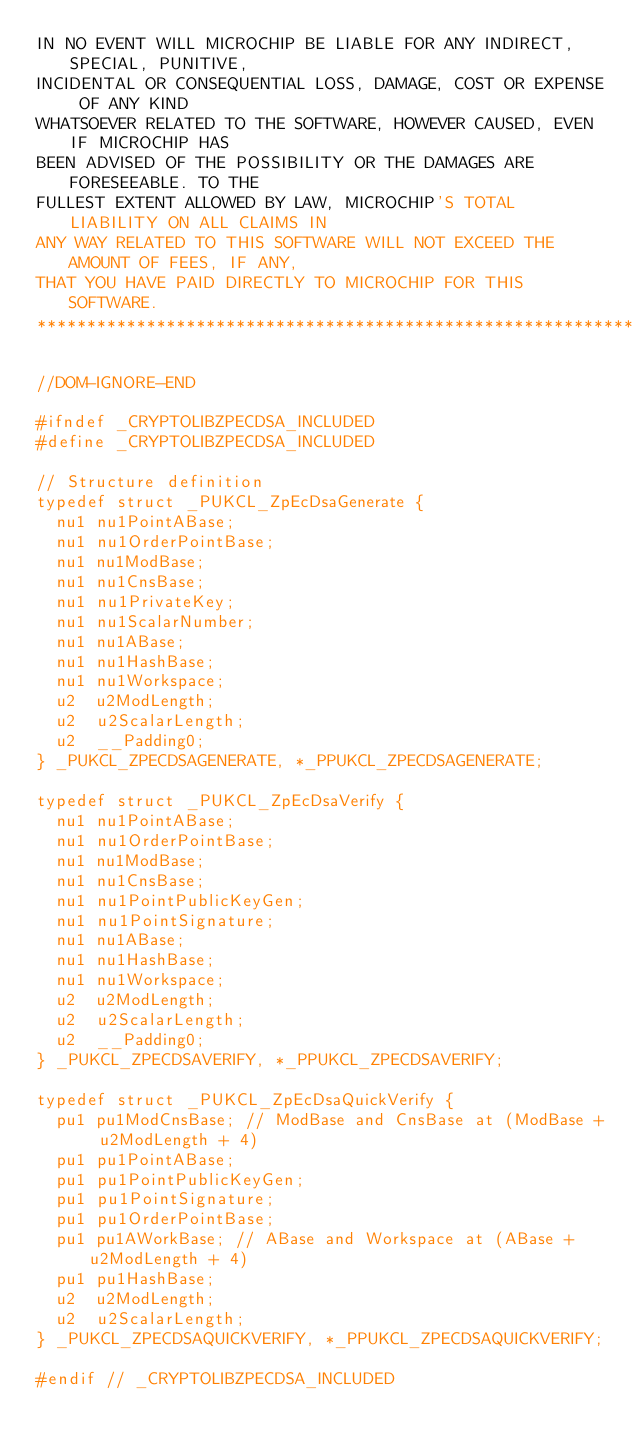Convert code to text. <code><loc_0><loc_0><loc_500><loc_500><_C_>IN NO EVENT WILL MICROCHIP BE LIABLE FOR ANY INDIRECT, SPECIAL, PUNITIVE, 
INCIDENTAL OR CONSEQUENTIAL LOSS, DAMAGE, COST OR EXPENSE OF ANY KIND 
WHATSOEVER RELATED TO THE SOFTWARE, HOWEVER CAUSED, EVEN IF MICROCHIP HAS 
BEEN ADVISED OF THE POSSIBILITY OR THE DAMAGES ARE FORESEEABLE. TO THE 
FULLEST EXTENT ALLOWED BY LAW, MICROCHIP'S TOTAL LIABILITY ON ALL CLAIMS IN 
ANY WAY RELATED TO THIS SOFTWARE WILL NOT EXCEED THE AMOUNT OF FEES, IF ANY, 
THAT YOU HAVE PAID DIRECTLY TO MICROCHIP FOR THIS SOFTWARE.
*****************************************************************************/

//DOM-IGNORE-END

#ifndef _CRYPTOLIBZPECDSA_INCLUDED
#define _CRYPTOLIBZPECDSA_INCLUDED

// Structure definition
typedef struct _PUKCL_ZpEcDsaGenerate {
	nu1 nu1PointABase;
	nu1 nu1OrderPointBase;
	nu1 nu1ModBase;
	nu1 nu1CnsBase;
	nu1 nu1PrivateKey;
	nu1 nu1ScalarNumber;
	nu1 nu1ABase;
	nu1 nu1HashBase;
	nu1 nu1Workspace;
	u2  u2ModLength;
	u2  u2ScalarLength;
	u2  __Padding0;
} _PUKCL_ZPECDSAGENERATE, *_PPUKCL_ZPECDSAGENERATE;

typedef struct _PUKCL_ZpEcDsaVerify {
	nu1 nu1PointABase;
	nu1 nu1OrderPointBase;
	nu1 nu1ModBase;
	nu1 nu1CnsBase;
	nu1 nu1PointPublicKeyGen;
	nu1 nu1PointSignature;
	nu1 nu1ABase;
	nu1 nu1HashBase;
	nu1 nu1Workspace;
	u2  u2ModLength;
	u2  u2ScalarLength;
	u2  __Padding0;
} _PUKCL_ZPECDSAVERIFY, *_PPUKCL_ZPECDSAVERIFY;

typedef struct _PUKCL_ZpEcDsaQuickVerify {
	pu1 pu1ModCnsBase; // ModBase and CnsBase at (ModBase + u2ModLength + 4)
	pu1 pu1PointABase;
	pu1 pu1PointPublicKeyGen;
	pu1 pu1PointSignature;
	pu1 pu1OrderPointBase;
	pu1 pu1AWorkBase; // ABase and Workspace at (ABase + u2ModLength + 4)
	pu1 pu1HashBase;
	u2  u2ModLength;
	u2  u2ScalarLength;
} _PUKCL_ZPECDSAQUICKVERIFY, *_PPUKCL_ZPECDSAQUICKVERIFY;

#endif // _CRYPTOLIBZPECDSA_INCLUDED
</code> 